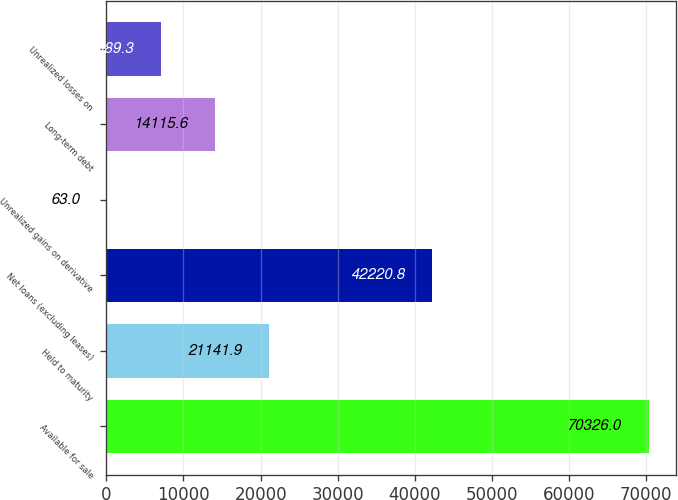Convert chart. <chart><loc_0><loc_0><loc_500><loc_500><bar_chart><fcel>Available for sale<fcel>Held to maturity<fcel>Net loans (excluding leases)<fcel>Unrealized gains on derivative<fcel>Long-term debt<fcel>Unrealized losses on<nl><fcel>70326<fcel>21141.9<fcel>42220.8<fcel>63<fcel>14115.6<fcel>7089.3<nl></chart> 